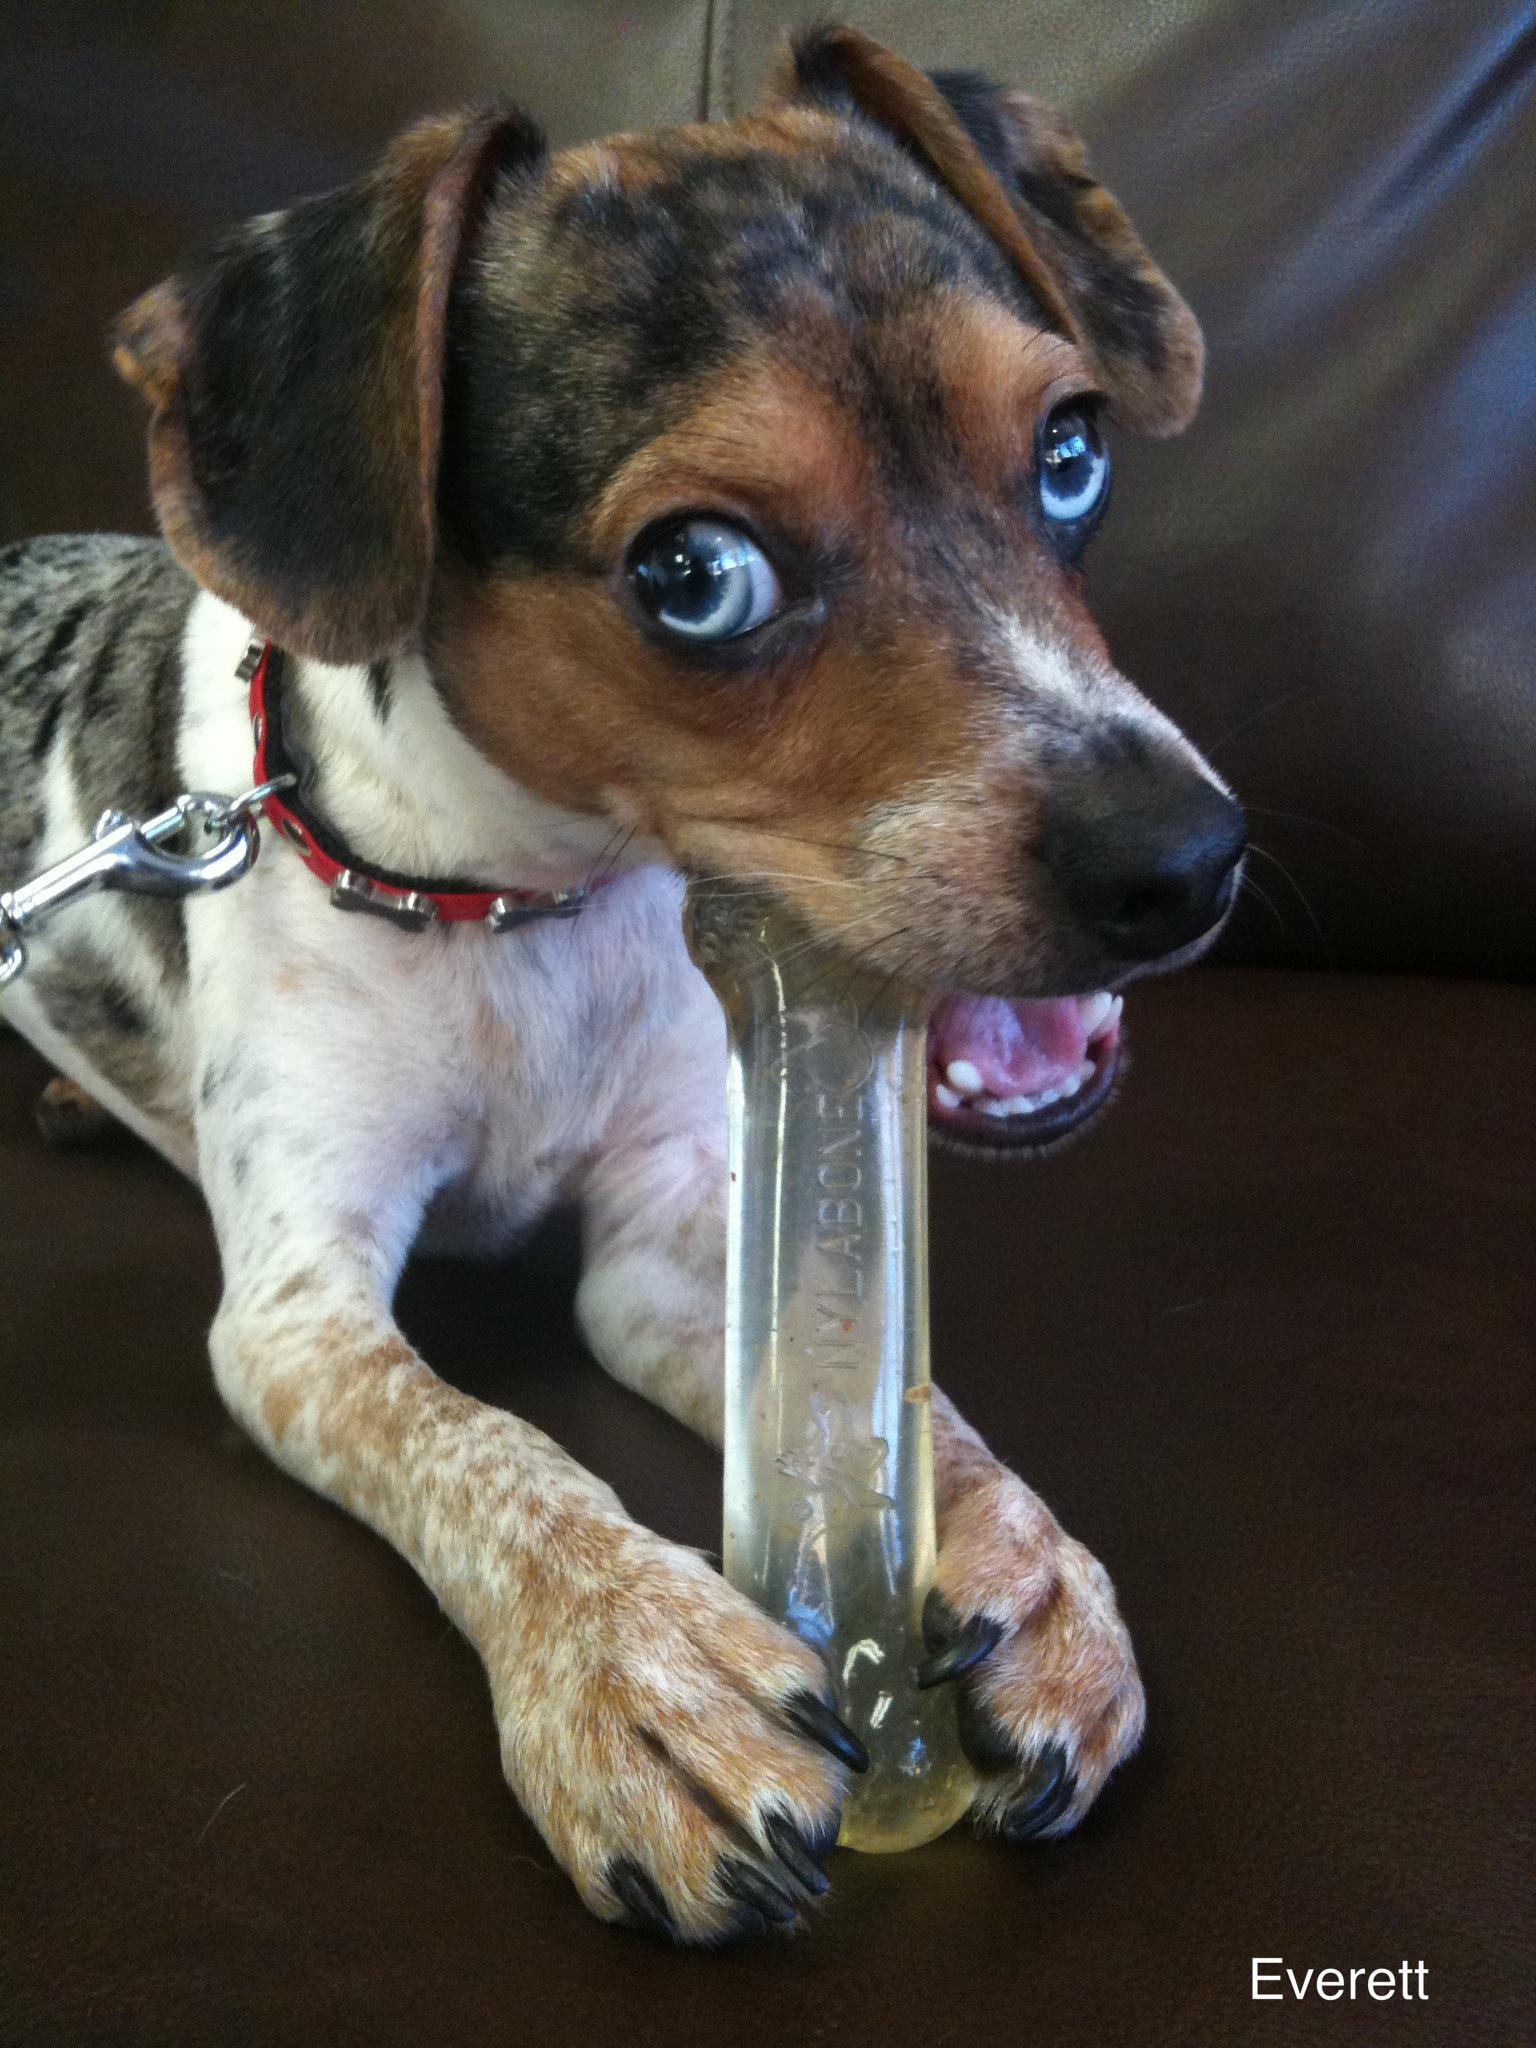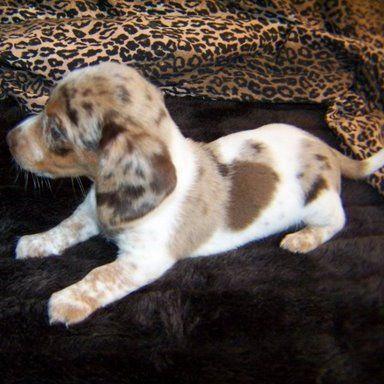The first image is the image on the left, the second image is the image on the right. Examine the images to the left and right. Is the description "The dog in one of the images has a red collar." accurate? Answer yes or no. Yes. The first image is the image on the left, the second image is the image on the right. Assess this claim about the two images: "Each image contains one hound dog posing on furniture, and at least one dog is on leather upholstery.". Correct or not? Answer yes or no. Yes. 